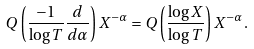Convert formula to latex. <formula><loc_0><loc_0><loc_500><loc_500>Q \left ( \frac { - 1 } { \log { T } } \frac { d } { d \alpha } \right ) X ^ { - \alpha } = Q \left ( \frac { \log { X } } { \log { T } } \right ) X ^ { - \alpha } .</formula> 